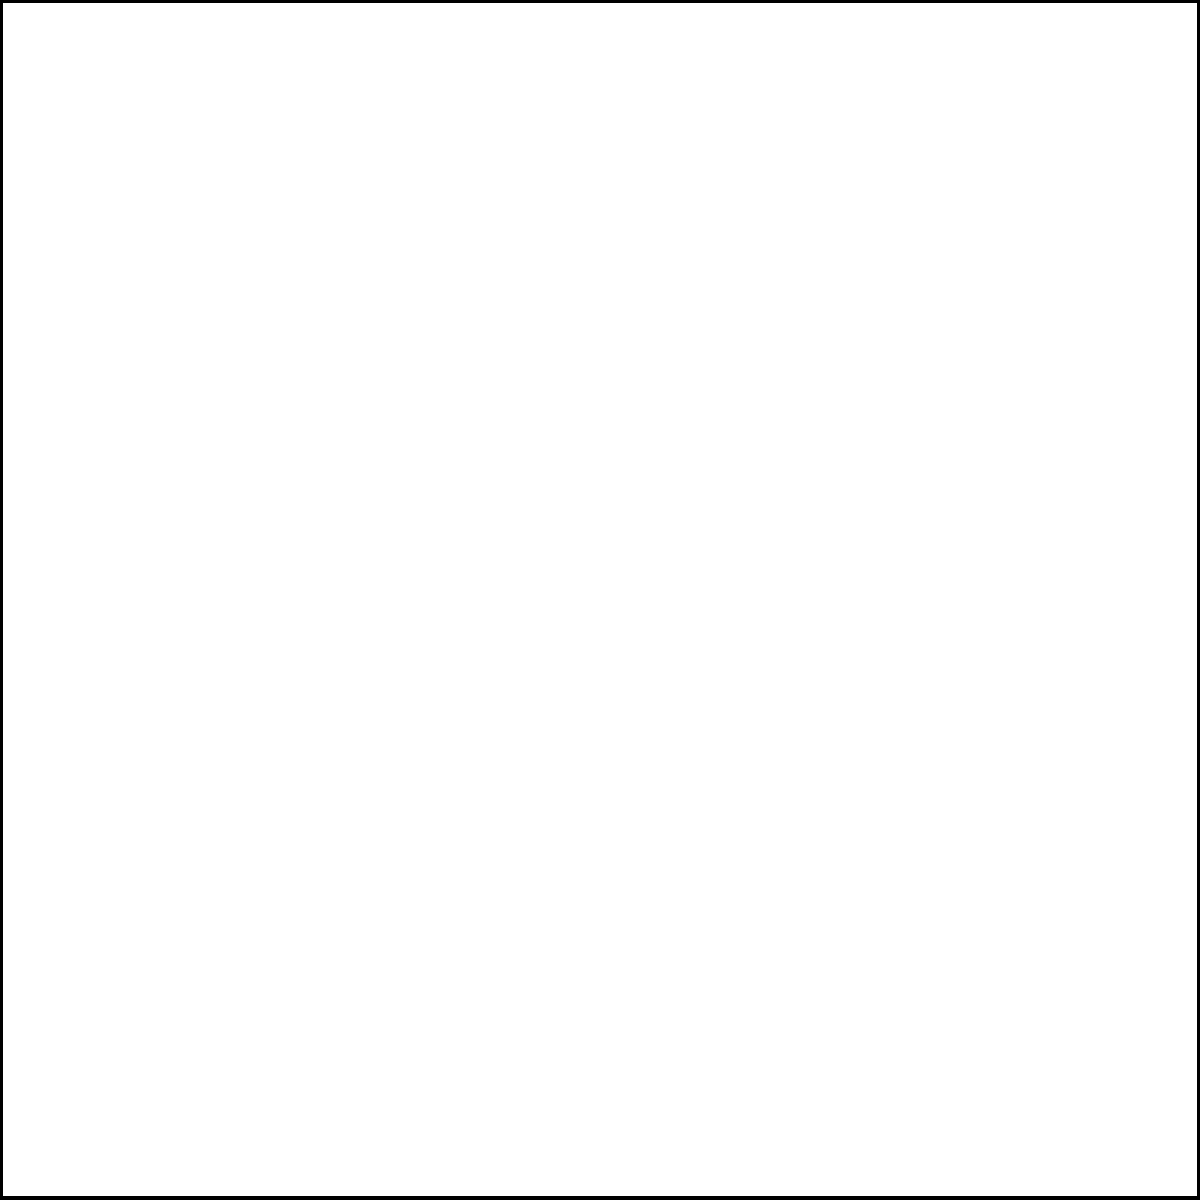In a typical mixing console signal flow, where would you insert an external effects processor to create a unique fusion sound without affecting the dry signal? To understand the optimal placement for an external effects processor in a mixing console signal flow, let's break down the process:

1. Input Stage: The audio signal enters the console through input channels.
2. EQ Section: The signal passes through equalization, where frequency adjustments are made.
3. Aux Send: This is a key point in the signal flow for our purpose. The Aux Send allows us to create a separate copy of the signal without affecting the main (dry) signal.
4. External Processing: The signal from the Aux Send can be routed to an external effects processor.
5. FX Return: The processed signal is brought back into the console via the FX Return.
6. Fader Section: The returned effect can be blended with the dry signal using faders.
7. Bus Section: Signals are routed to the appropriate output buses.
8. Main Output: The final mixed signal is sent to the main output.

By using the Aux Send to route the signal to an external effects processor and bringing it back via the FX Return, we can:
a) Preserve the original dry signal
b) Control the amount of effect applied by adjusting the Aux Send level
c) Blend the wet (effected) signal with the dry signal using the FX Return fader

This method allows for creative effects processing without compromising the integrity of the original signal, which is crucial for creating unique fusion sounds while maintaining clarity and balance in the mix.
Answer: Aux Send and FX Return 